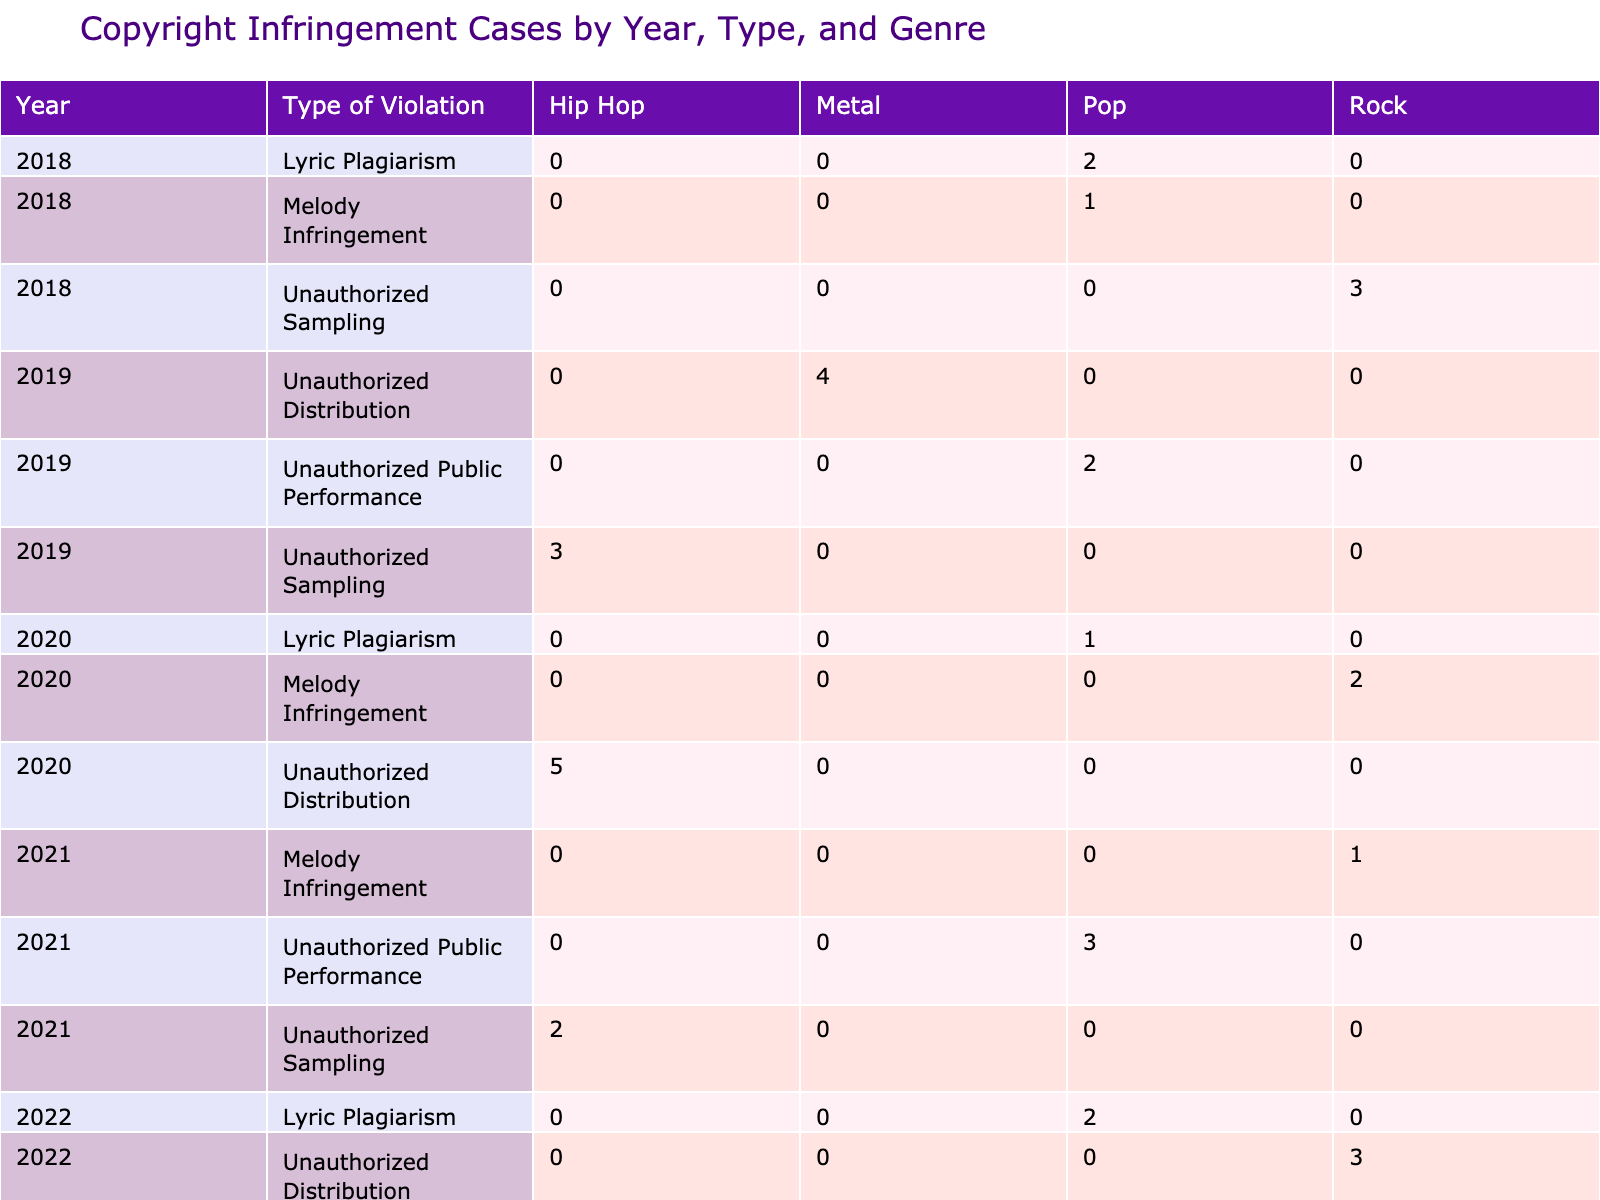What was the total number of cases for unauthorized sampling in 2019? In 2019, the only artist listed for unauthorized sampling is Kendrick Lamar with 3 cases. Therefore, the total number of cases is 3.
Answer: 3 Which year had the highest damages awarded for unauthorized distribution? In 2019, Metallica had 4 cases with damages of 200,000. In 2020, Drake had 5 cases with damages of 250,000. Therefore, the highest damages awarded for unauthorized distribution is 250,000 in 2020.
Answer: 250000 How many total cases were there for melody infringement from 2018 to 2022? The cases for melody infringement are as follows: 1 in 2018 (Ed Sheeran), 2 in 2020 (Foo Fighters), 1 in 2021 (Coldplay), totaling 4 cases.
Answer: 4 Did Beyoncé incur damages over 100,000 for any copyright infringement case? Beyoncé had 2 cases for lyric plagiarism in 2018 with damages awarded of 75,000. This is below 100,000. Therefore, the answer is no.
Answer: No What is the average number of cases for unauthorized public performance from 2019 to 2022? The number of cases for unauthorized public performance from 2019 to 2022 are: 2 in 2019 (Taylor Swift), 3 in 2021 (Lady Gaga), and 4 in 2022 (Dua Lipa), totaling 9 cases across 3 years. The average is 9/3 = 3.
Answer: 3 Which genre had the most cases of unauthorized sampling across all years listed? The data shows 3 unauthorized sampling cases in 2019 (Kendrick Lamar) and 2 cases in 2021 (Eminem). Since there are no other violations for this type listed under different genres, hip hop is the genre with the highest number of unauthorized sampling cases.
Answer: Hip Hop How many total damages were awarded for lyric plagiarism cases from 2018 to 2022? The total damages for lyric plagiarism are: 75,000 (Beyoncé, 2018) + 80,000 (Adele, 2020) + 110,000 (Billie Eilish, 2022) = 265,000.
Answer: 265000 In which year did unauthorized distribution have the highest number of cases? In 2019, unauthorized distribution had 4 cases (Metallica). In 2020, it reached 5 cases (Drake). Therefore, the year with the highest number of cases for unauthorized distribution is 2020.
Answer: 2020 